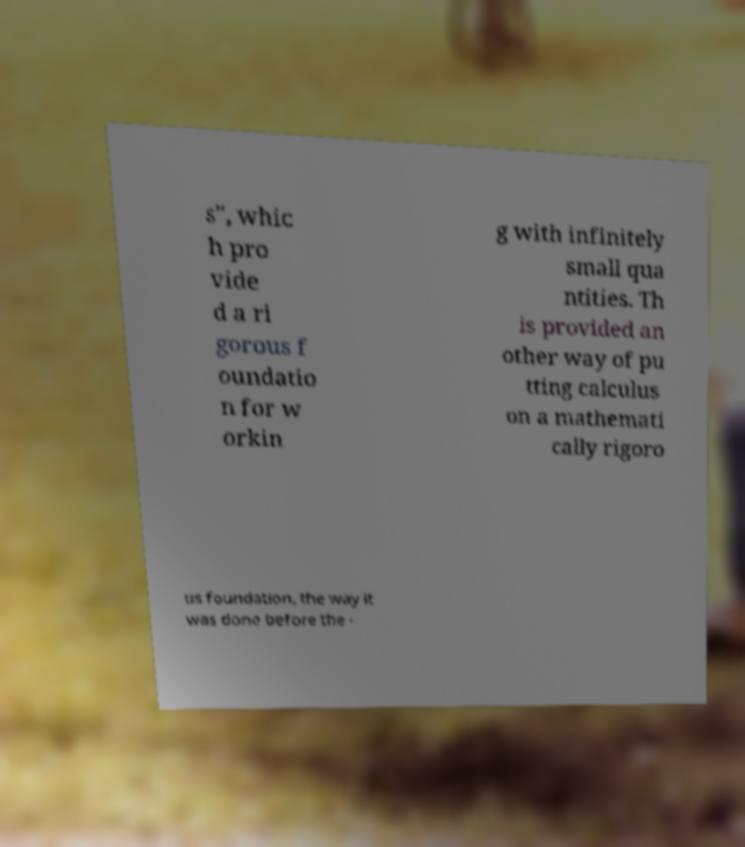Could you assist in decoding the text presented in this image and type it out clearly? s", whic h pro vide d a ri gorous f oundatio n for w orkin g with infinitely small qua ntities. Th is provided an other way of pu tting calculus on a mathemati cally rigoro us foundation, the way it was done before the - 